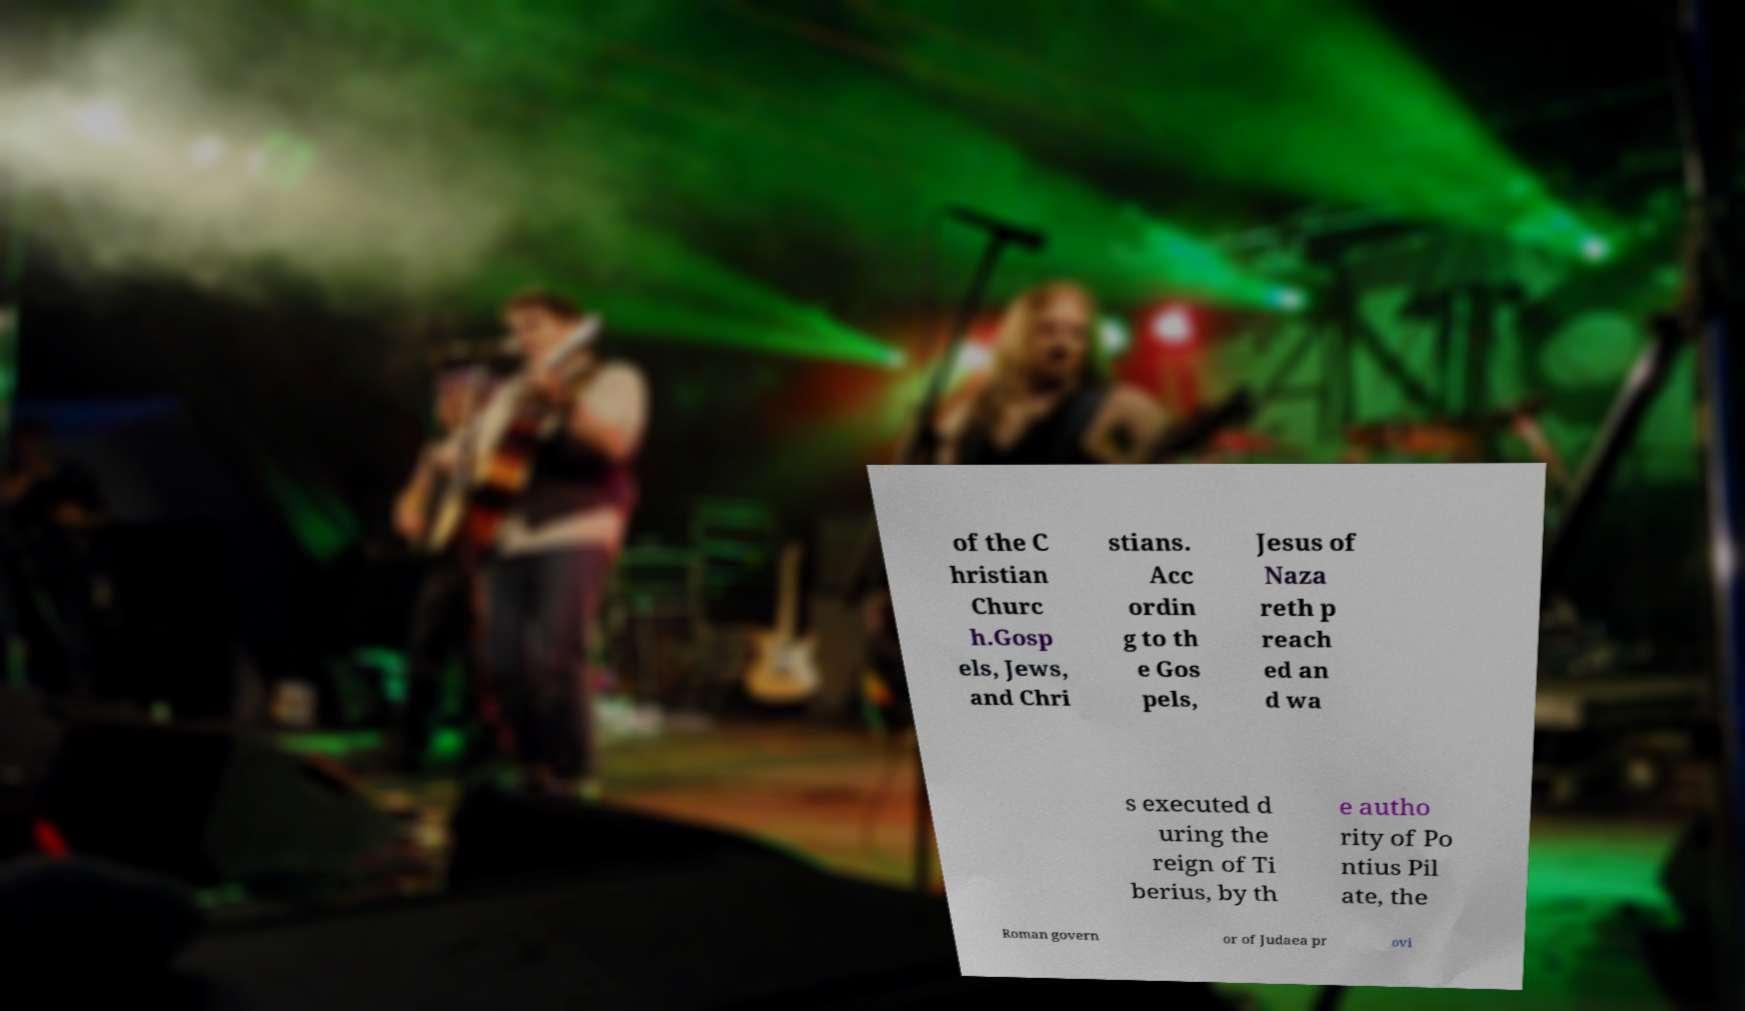Could you assist in decoding the text presented in this image and type it out clearly? of the C hristian Churc h.Gosp els, Jews, and Chri stians. Acc ordin g to th e Gos pels, Jesus of Naza reth p reach ed an d wa s executed d uring the reign of Ti berius, by th e autho rity of Po ntius Pil ate, the Roman govern or of Judaea pr ovi 